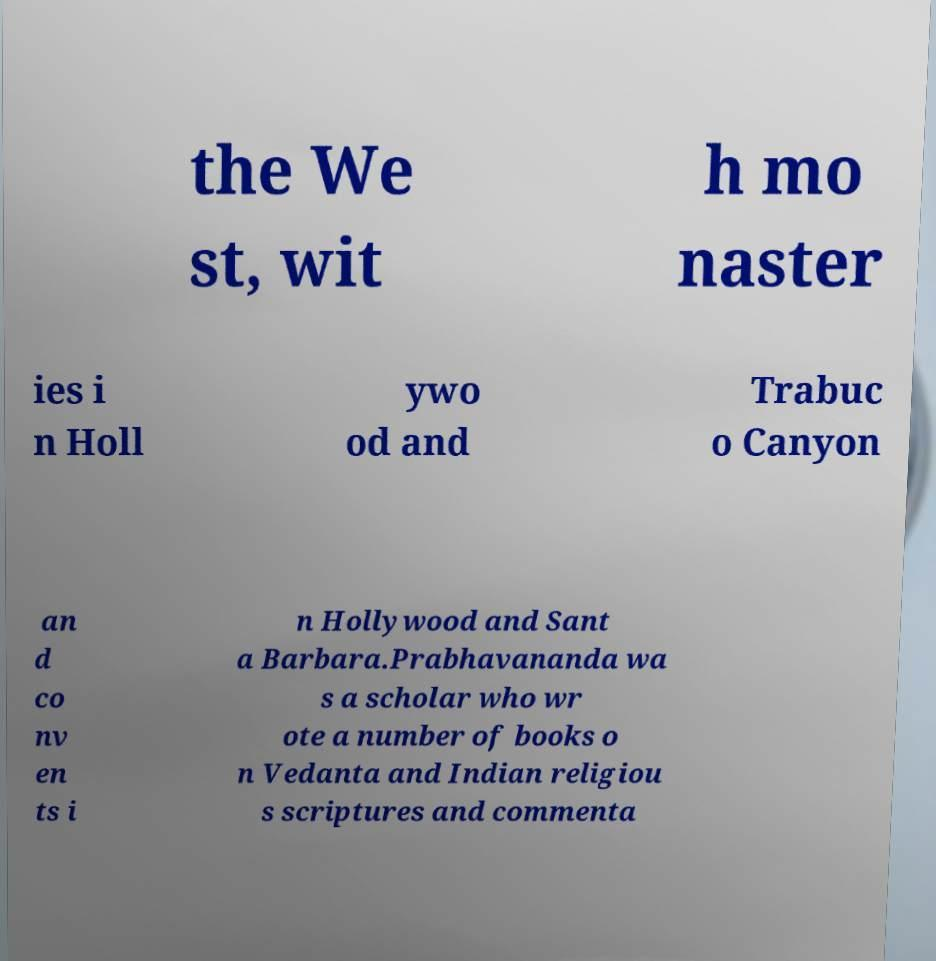Please read and relay the text visible in this image. What does it say? the We st, wit h mo naster ies i n Holl ywo od and Trabuc o Canyon an d co nv en ts i n Hollywood and Sant a Barbara.Prabhavananda wa s a scholar who wr ote a number of books o n Vedanta and Indian religiou s scriptures and commenta 